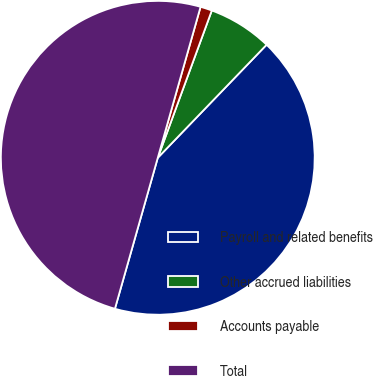<chart> <loc_0><loc_0><loc_500><loc_500><pie_chart><fcel>Payroll and related benefits<fcel>Other accrued liabilities<fcel>Accounts payable<fcel>Total<nl><fcel>42.21%<fcel>6.6%<fcel>1.2%<fcel>50.0%<nl></chart> 